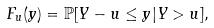<formula> <loc_0><loc_0><loc_500><loc_500>F _ { u } ( y ) = \mathbb { P } [ Y - u \leq y | Y > u ] ,</formula> 